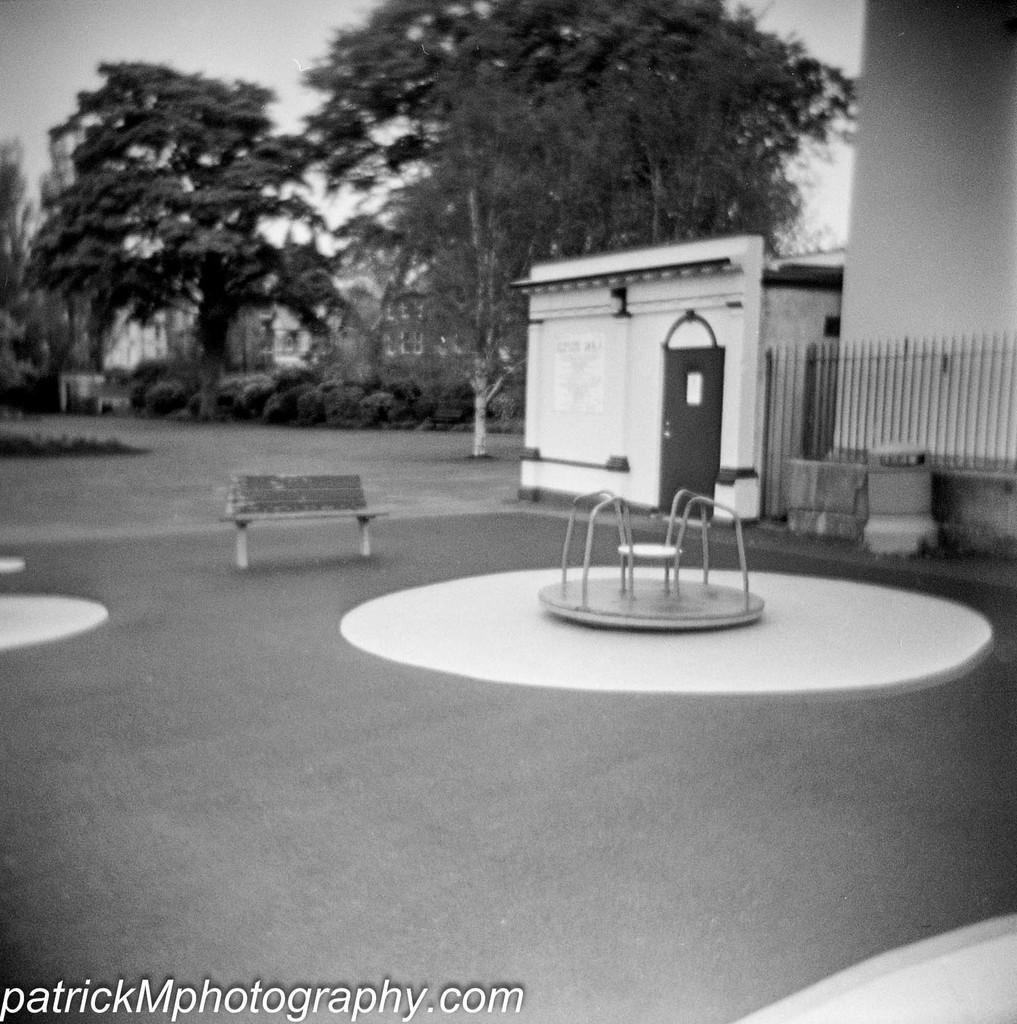In one or two sentences, can you explain what this image depicts? It is a black and white image. I can see a bench, roundabout toy and a small house. In the background, there are trees and bushes. At the bottom of the image, this is the watermark. 